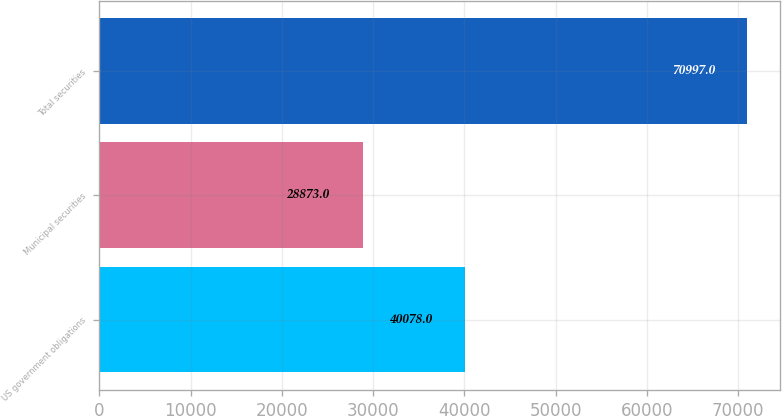<chart> <loc_0><loc_0><loc_500><loc_500><bar_chart><fcel>US government obligations<fcel>Municipal securities<fcel>Total securities<nl><fcel>40078<fcel>28873<fcel>70997<nl></chart> 